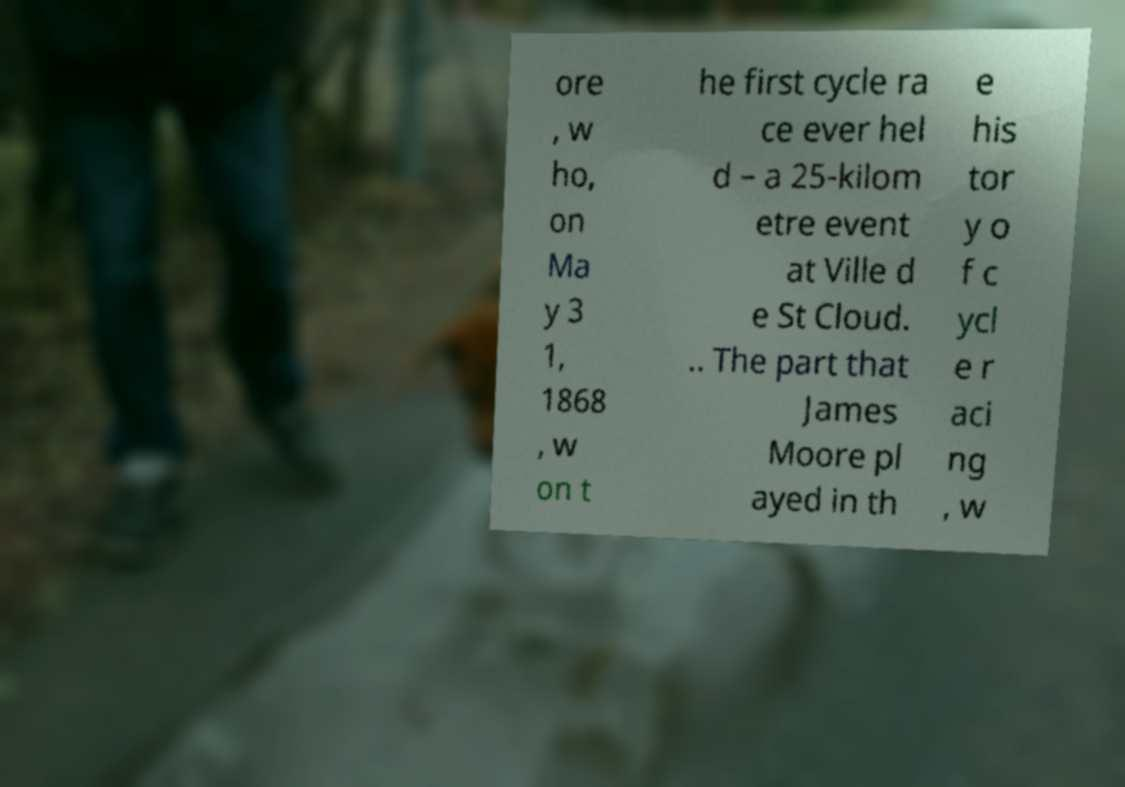Could you assist in decoding the text presented in this image and type it out clearly? ore , w ho, on Ma y 3 1, 1868 , w on t he first cycle ra ce ever hel d – a 25-kilom etre event at Ville d e St Cloud. .. The part that James Moore pl ayed in th e his tor y o f c ycl e r aci ng , w 